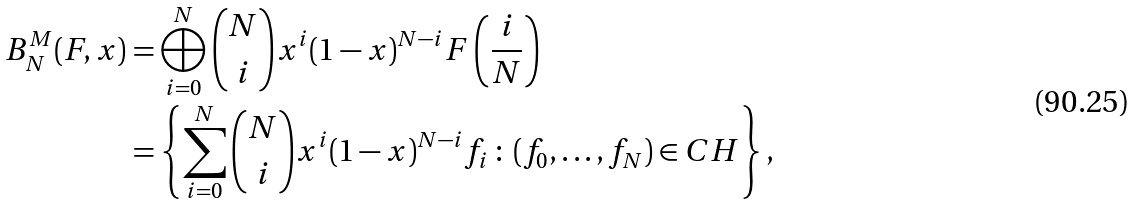<formula> <loc_0><loc_0><loc_500><loc_500>B ^ { M } _ { N } ( F , x ) & = \bigoplus _ { i = 0 } ^ { N } { N \choose i } x ^ { i } ( 1 - x ) ^ { N - i } F \left ( \frac { i } { N } \right ) \\ & = \left \{ \sum _ { i = 0 } ^ { N } { N \choose i } x ^ { i } ( 1 - x ) ^ { N - i } f _ { i } \, \colon \, ( f _ { 0 } , \dots , f _ { N } ) \in C H \right \} ,</formula> 